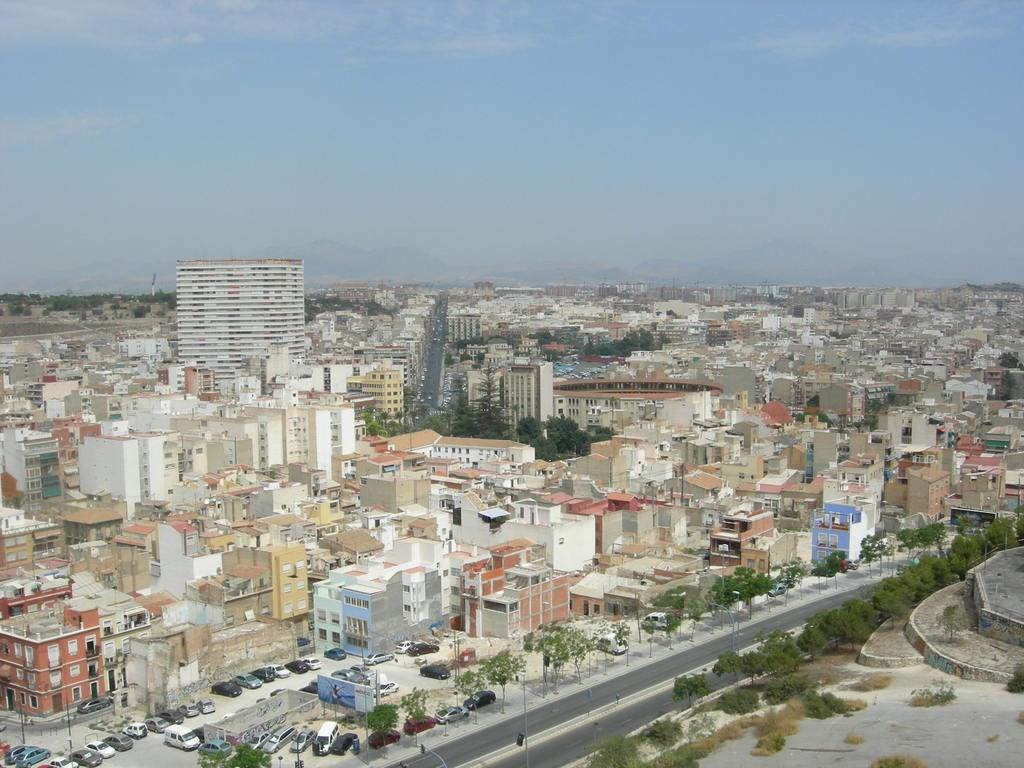What type of structures can be seen in the image? There are buildings in the image. What natural elements are present in the image? There are trees in the image. What man-made objects can be seen in the image? There are vehicles in the image. What vertical structures are present in the image? There are poles in the image. What is visible at the top of the image? The sky is visible at the top of the image. How many bikes are parked on the floor in the image? There is no mention of bikes or a floor in the image, so we cannot determine the number of bikes or their location. 